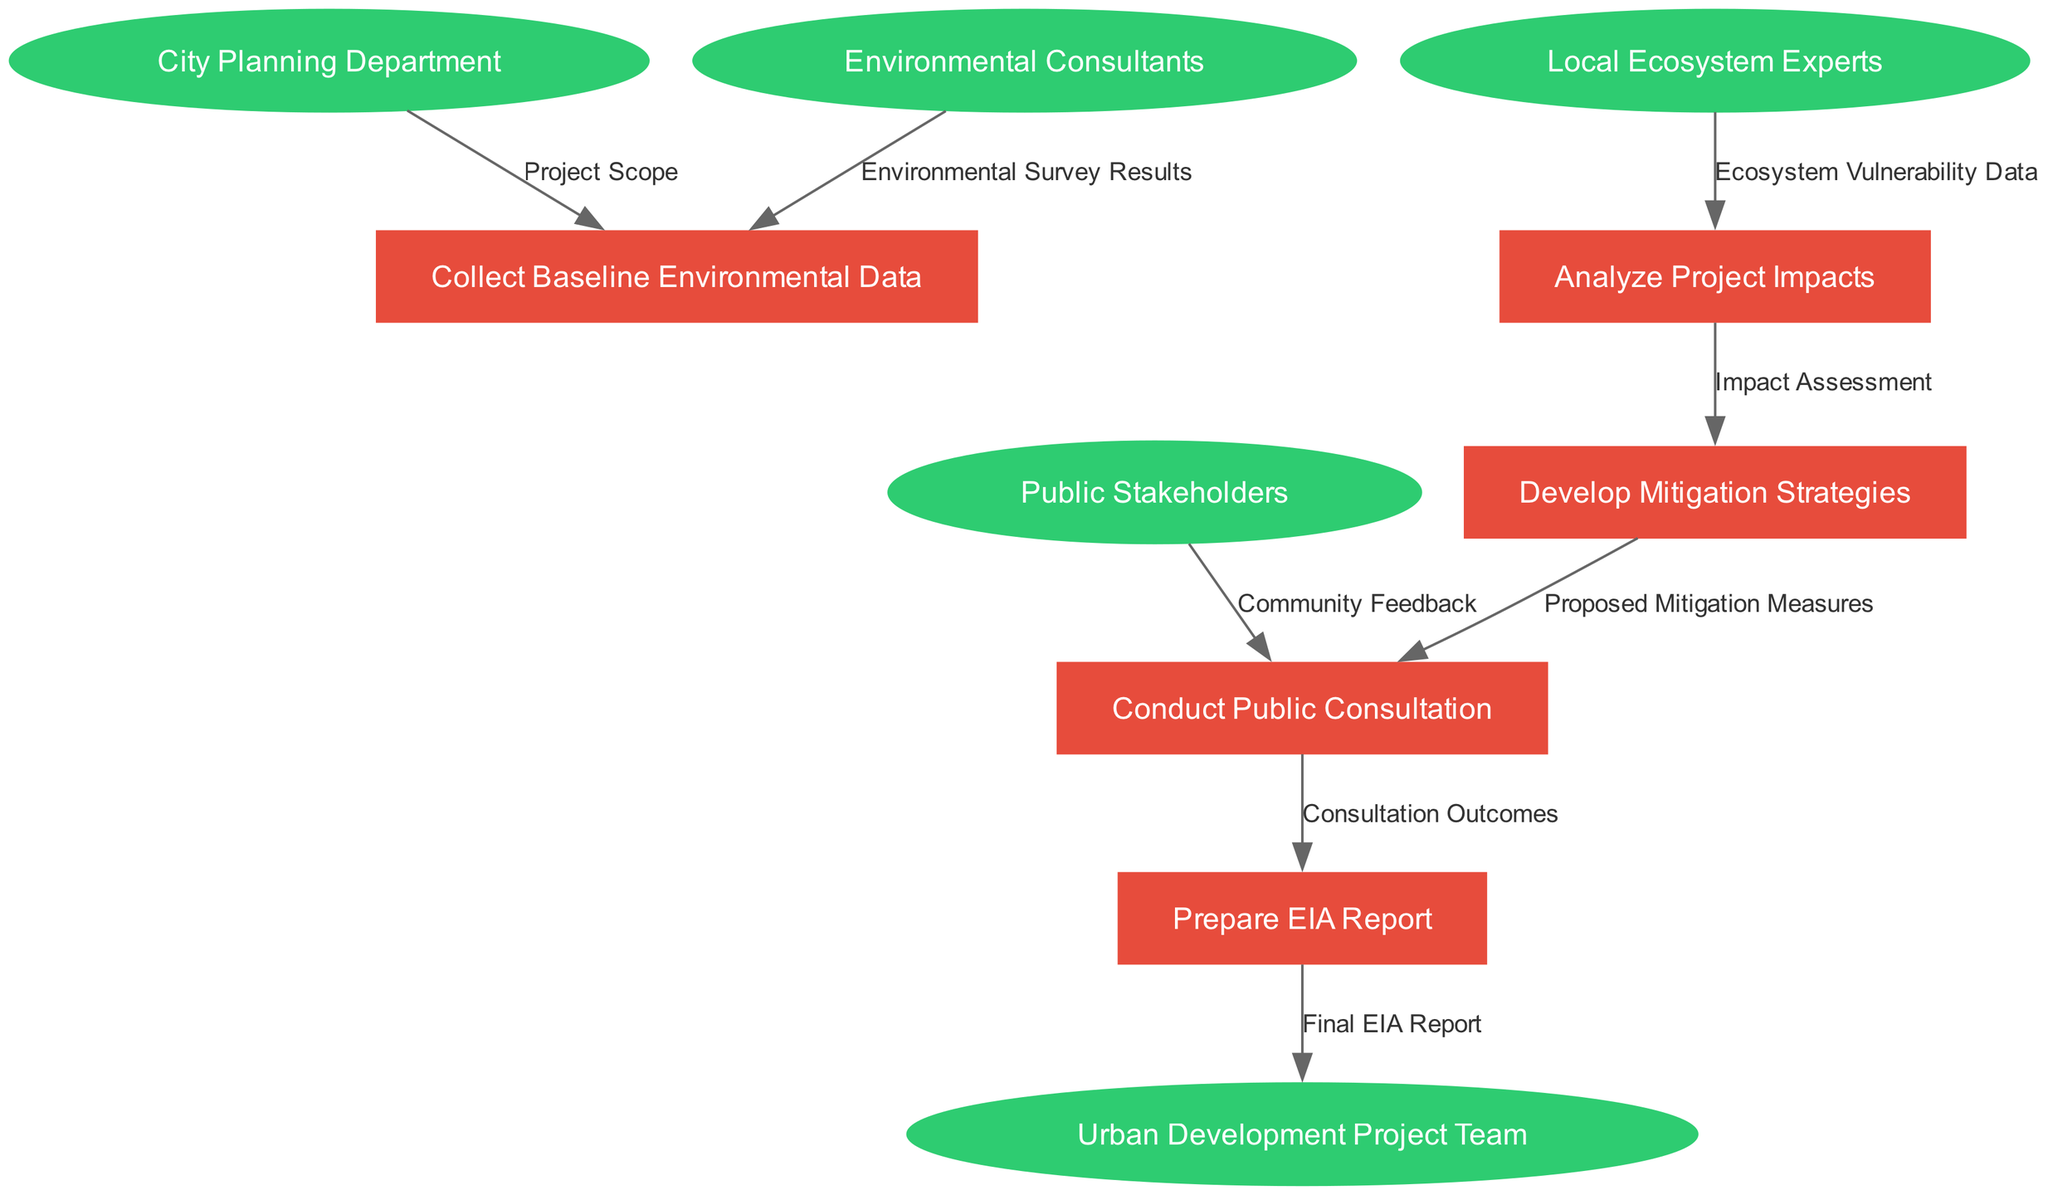What are the entities involved in the diagram? The diagram includes five entities: City Planning Department, Environmental Consultants, Public Stakeholders, Local Ecosystem Experts, and Urban Development Project Team.
Answer: City Planning Department, Environmental Consultants, Public Stakeholders, Local Ecosystem Experts, Urban Development Project Team How many processes are listed in the diagram? There are five specific processes listed in the diagram: Collect Baseline Environmental Data, Analyze Project Impacts, Develop Mitigation Strategies, Conduct Public Consultation, and Prepare EIA Report. Counting these gives a total of five processes.
Answer: 5 Which entity provides ecosystem vulnerability data? The Local Ecosystem Experts are responsible for providing ecosystem vulnerability data in the diagram as indicated by the flow from them to the Analyze Project Impacts process.
Answer: Local Ecosystem Experts What information flows from Analyze Project Impacts to Develop Mitigation Strategies? The diagram shows that the flow from Analyze Project Impacts to Develop Mitigation Strategies is labeled as Impact Assessment. This indicates that the results from analyzing impacts are used to inform the mitigation strategies.
Answer: Impact Assessment Which process is receiving community feedback? Conduct Public Consultation is the process that receives community feedback, as indicated by the flow of data from Public Stakeholders to the Conduct Public Consultation process.
Answer: Conduct Public Consultation What is the final product of the environmental impact assessment process? The final product of the process is the Final EIA Report, which flows from the Prepare EIA Report to the Urban Development Project Team.
Answer: Final EIA Report What do the proposed mitigation measures come from? The Proposed Mitigation Measures come from the Develop Mitigation Strategies process, which indicates that upon identifying impacts, strategies are developed to mitigate those impacts.
Answer: Develop Mitigation Strategies How many flows are there between the processes? The diagram shows a total of seven flows between the various processes, illustrating the path of data and information through the assessment process.
Answer: 7 What is the label of the flow from Environmental Consultants to Collect Baseline Environmental Data? The label for the flow from Environmental Consultants to the Collect Baseline Environmental Data process is Environmental Survey Results, indicating what information is being provided.
Answer: Environmental Survey Results 